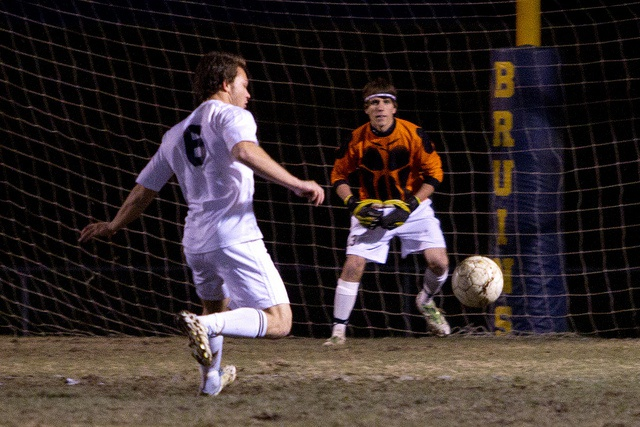Describe the objects in this image and their specific colors. I can see people in black, lavender, and purple tones, people in black, lavender, maroon, and gray tones, and sports ball in black, lightgray, and gray tones in this image. 